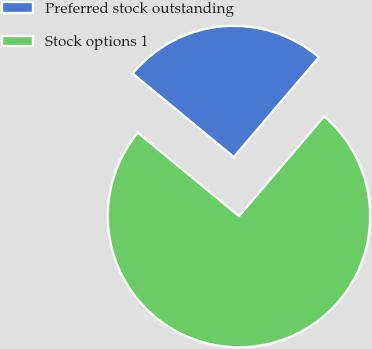Convert chart to OTSL. <chart><loc_0><loc_0><loc_500><loc_500><pie_chart><fcel>Preferred stock outstanding<fcel>Stock options 1<nl><fcel>25.27%<fcel>74.73%<nl></chart> 